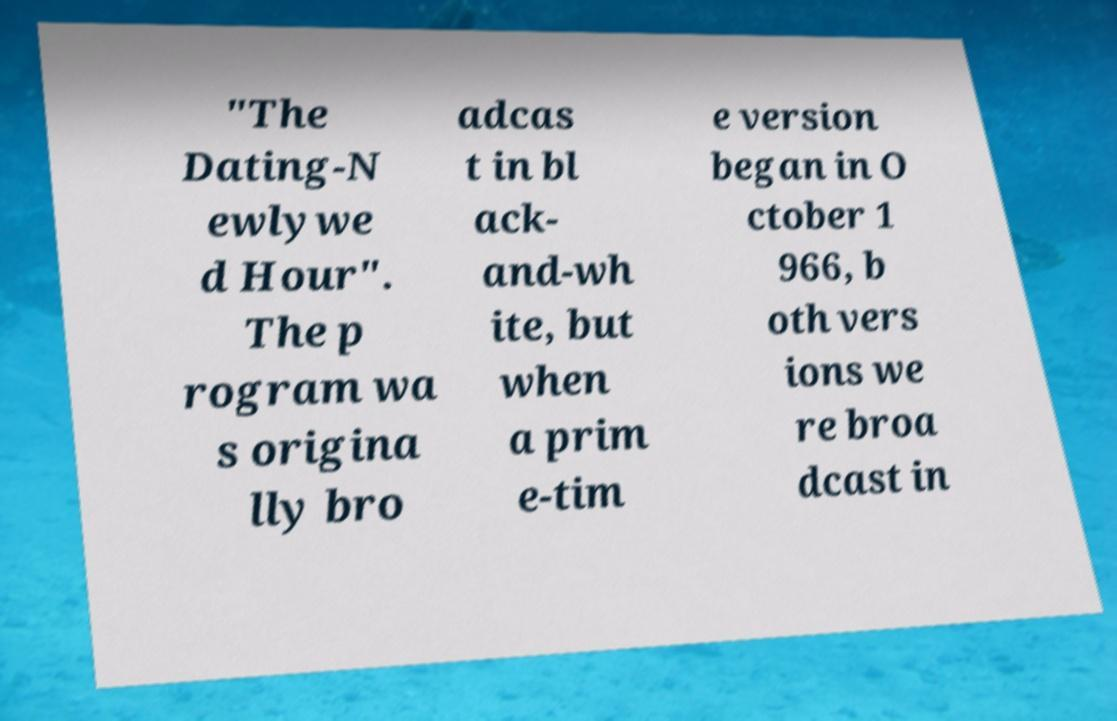What messages or text are displayed in this image? I need them in a readable, typed format. "The Dating-N ewlywe d Hour". The p rogram wa s origina lly bro adcas t in bl ack- and-wh ite, but when a prim e-tim e version began in O ctober 1 966, b oth vers ions we re broa dcast in 